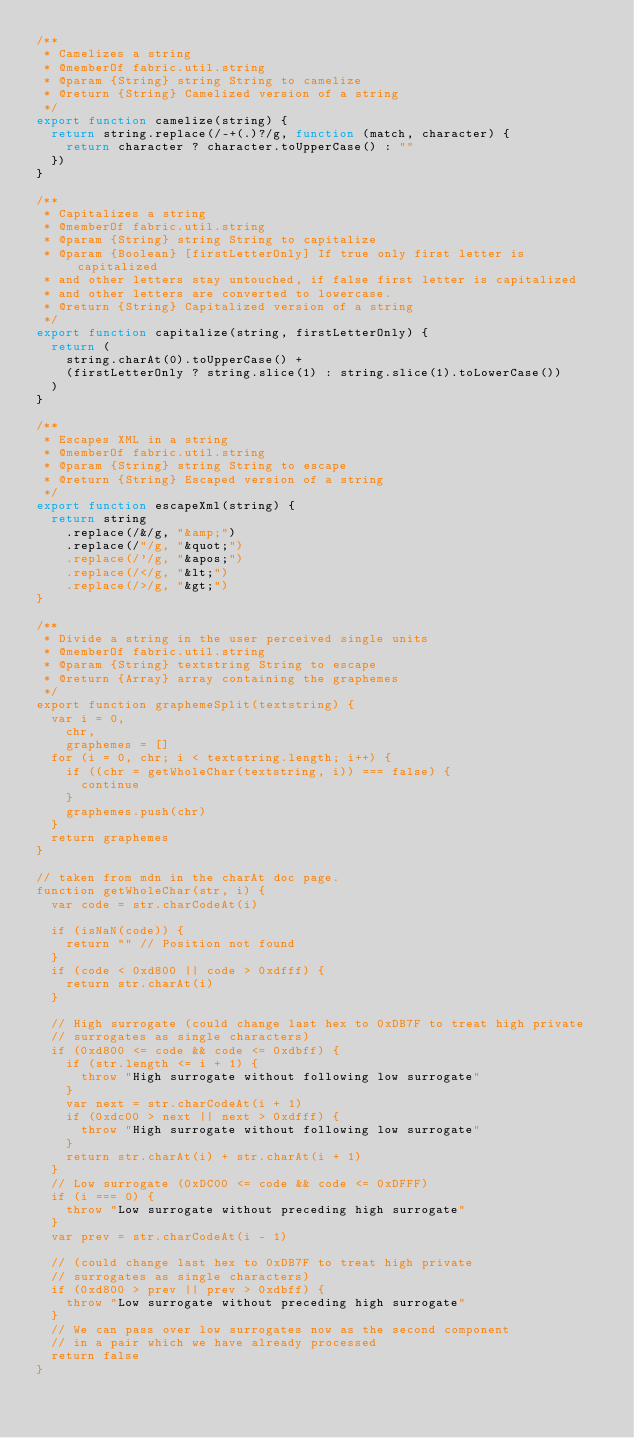<code> <loc_0><loc_0><loc_500><loc_500><_JavaScript_>/**
 * Camelizes a string
 * @memberOf fabric.util.string
 * @param {String} string String to camelize
 * @return {String} Camelized version of a string
 */
export function camelize(string) {
  return string.replace(/-+(.)?/g, function (match, character) {
    return character ? character.toUpperCase() : ""
  })
}

/**
 * Capitalizes a string
 * @memberOf fabric.util.string
 * @param {String} string String to capitalize
 * @param {Boolean} [firstLetterOnly] If true only first letter is capitalized
 * and other letters stay untouched, if false first letter is capitalized
 * and other letters are converted to lowercase.
 * @return {String} Capitalized version of a string
 */
export function capitalize(string, firstLetterOnly) {
  return (
    string.charAt(0).toUpperCase() +
    (firstLetterOnly ? string.slice(1) : string.slice(1).toLowerCase())
  )
}

/**
 * Escapes XML in a string
 * @memberOf fabric.util.string
 * @param {String} string String to escape
 * @return {String} Escaped version of a string
 */
export function escapeXml(string) {
  return string
    .replace(/&/g, "&amp;")
    .replace(/"/g, "&quot;")
    .replace(/'/g, "&apos;")
    .replace(/</g, "&lt;")
    .replace(/>/g, "&gt;")
}

/**
 * Divide a string in the user perceived single units
 * @memberOf fabric.util.string
 * @param {String} textstring String to escape
 * @return {Array} array containing the graphemes
 */
export function graphemeSplit(textstring) {
  var i = 0,
    chr,
    graphemes = []
  for (i = 0, chr; i < textstring.length; i++) {
    if ((chr = getWholeChar(textstring, i)) === false) {
      continue
    }
    graphemes.push(chr)
  }
  return graphemes
}

// taken from mdn in the charAt doc page.
function getWholeChar(str, i) {
  var code = str.charCodeAt(i)

  if (isNaN(code)) {
    return "" // Position not found
  }
  if (code < 0xd800 || code > 0xdfff) {
    return str.charAt(i)
  }

  // High surrogate (could change last hex to 0xDB7F to treat high private
  // surrogates as single characters)
  if (0xd800 <= code && code <= 0xdbff) {
    if (str.length <= i + 1) {
      throw "High surrogate without following low surrogate"
    }
    var next = str.charCodeAt(i + 1)
    if (0xdc00 > next || next > 0xdfff) {
      throw "High surrogate without following low surrogate"
    }
    return str.charAt(i) + str.charAt(i + 1)
  }
  // Low surrogate (0xDC00 <= code && code <= 0xDFFF)
  if (i === 0) {
    throw "Low surrogate without preceding high surrogate"
  }
  var prev = str.charCodeAt(i - 1)

  // (could change last hex to 0xDB7F to treat high private
  // surrogates as single characters)
  if (0xd800 > prev || prev > 0xdbff) {
    throw "Low surrogate without preceding high surrogate"
  }
  // We can pass over low surrogates now as the second component
  // in a pair which we have already processed
  return false
}
</code> 